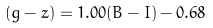<formula> <loc_0><loc_0><loc_500><loc_500>( g - z ) = 1 . 0 0 ( B - I ) - 0 . 6 8</formula> 